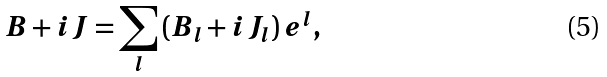<formula> <loc_0><loc_0><loc_500><loc_500>B + i J = \sum _ { l } \, ( B _ { l } + i J _ { l } ) \, e ^ { l } ,</formula> 